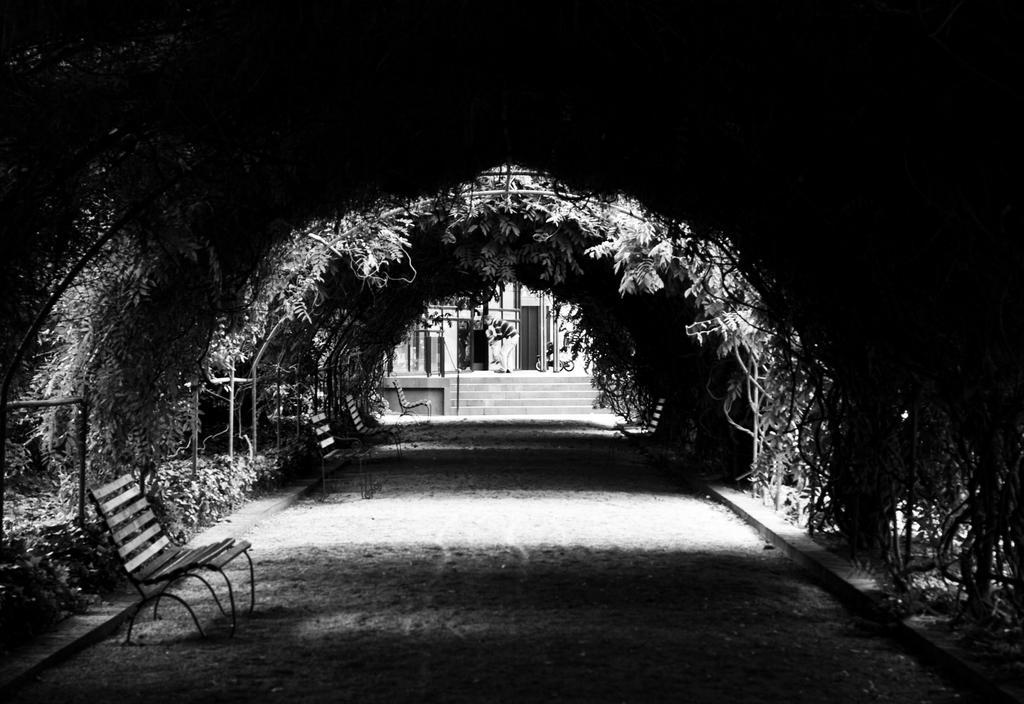In one or two sentences, can you explain what this image depicts? In this image I can see benches, fence, grass, plants, creepers, shed, metal rods, steps and a building. This image is taken may be during a day. 